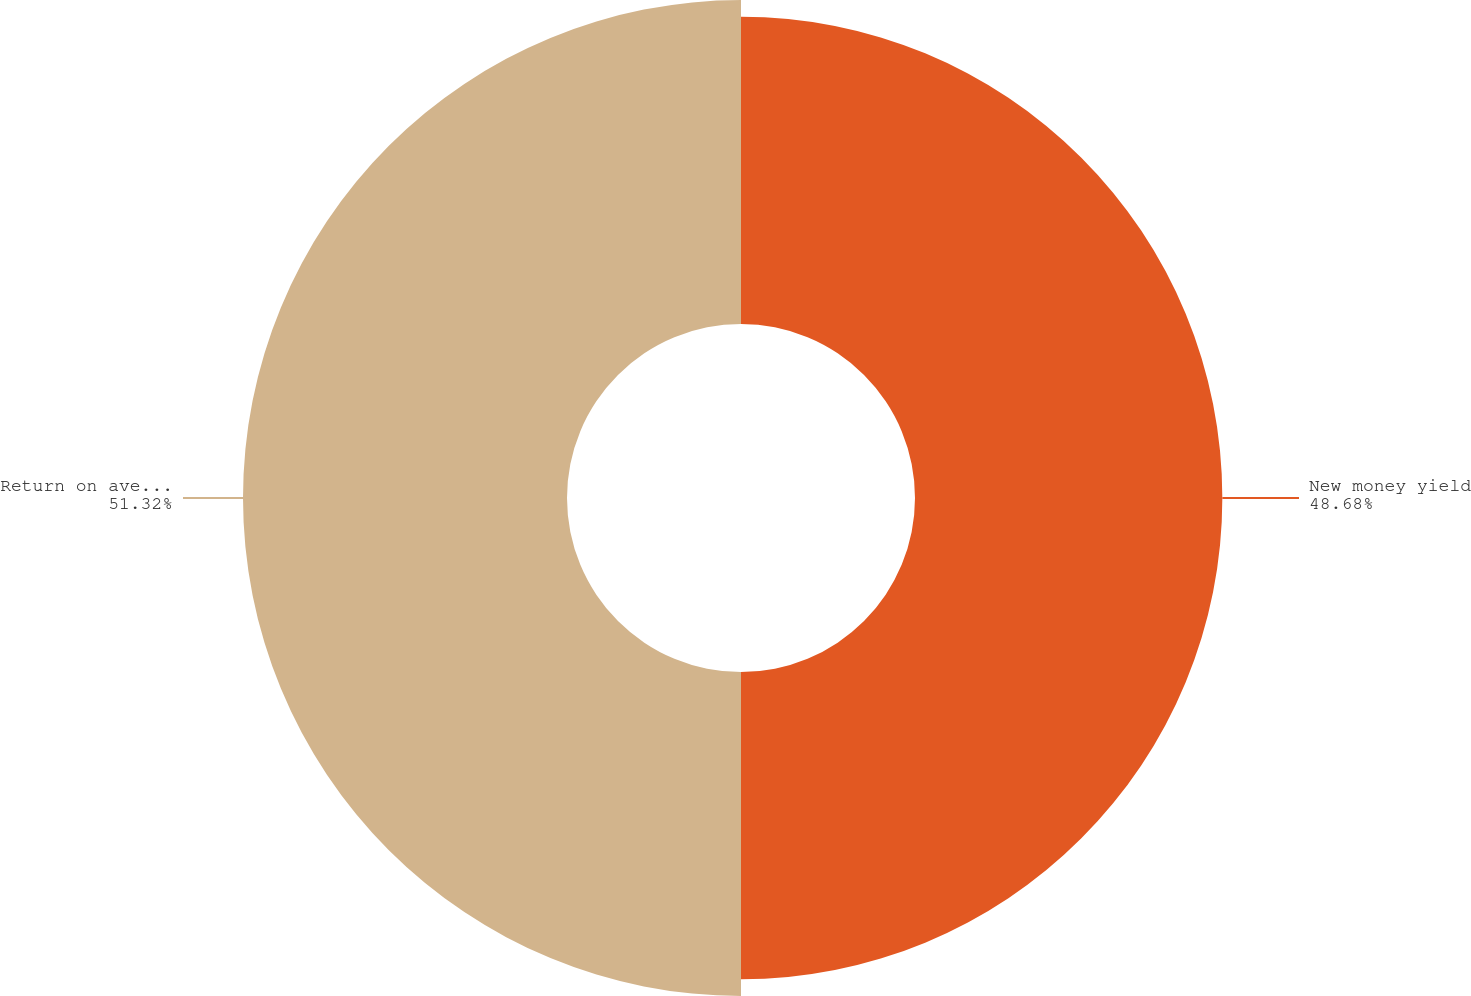Convert chart. <chart><loc_0><loc_0><loc_500><loc_500><pie_chart><fcel>New money yield<fcel>Return on average invested<nl><fcel>48.68%<fcel>51.32%<nl></chart> 